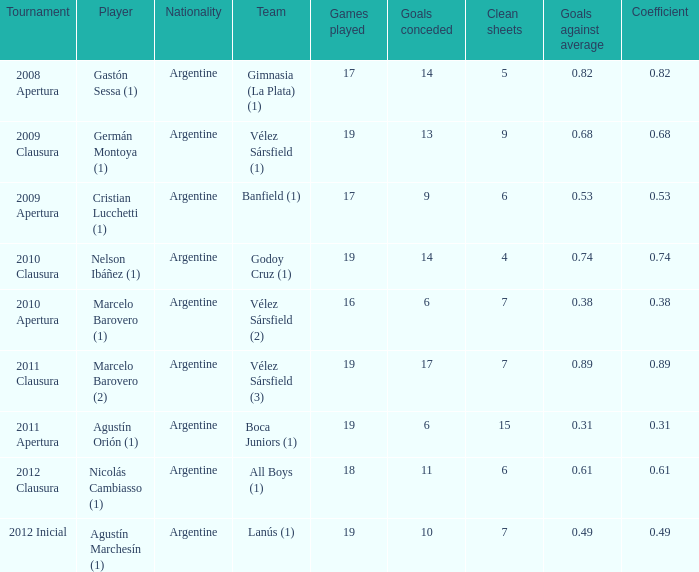Which team was in the 2012 clausura tournament? All Boys (1). 